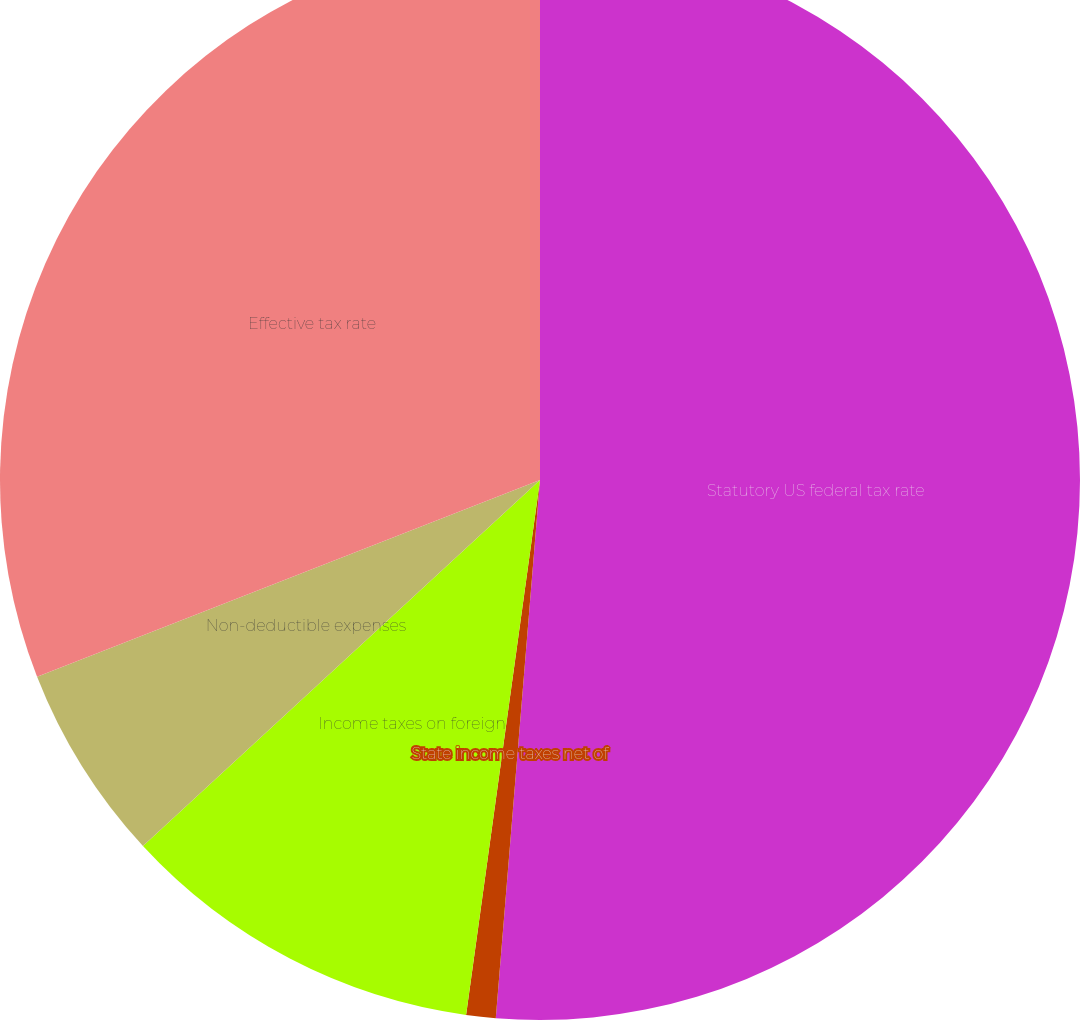Convert chart. <chart><loc_0><loc_0><loc_500><loc_500><pie_chart><fcel>Statutory US federal tax rate<fcel>State income taxes net of<fcel>Income taxes on foreign<fcel>Non-deductible expenses<fcel>Effective tax rate<nl><fcel>51.3%<fcel>0.88%<fcel>10.96%<fcel>5.92%<fcel>30.93%<nl></chart> 